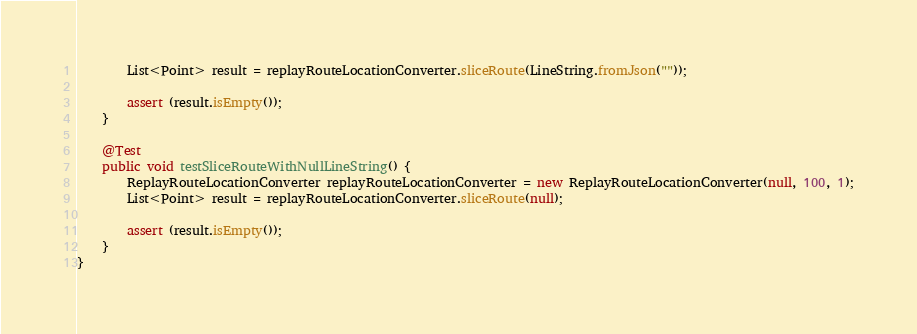<code> <loc_0><loc_0><loc_500><loc_500><_Java_>        List<Point> result = replayRouteLocationConverter.sliceRoute(LineString.fromJson(""));

        assert (result.isEmpty());
    }

    @Test
    public void testSliceRouteWithNullLineString() {
        ReplayRouteLocationConverter replayRouteLocationConverter = new ReplayRouteLocationConverter(null, 100, 1);
        List<Point> result = replayRouteLocationConverter.sliceRoute(null);

        assert (result.isEmpty());
    }
}</code> 